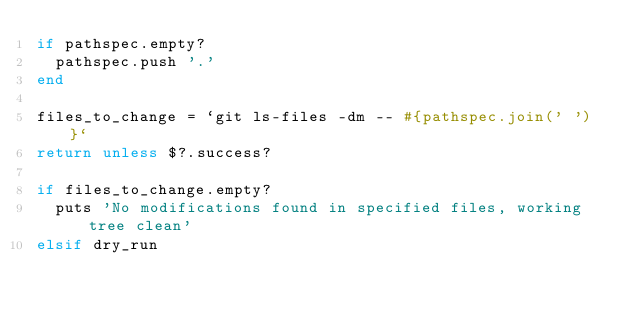Convert code to text. <code><loc_0><loc_0><loc_500><loc_500><_Ruby_>if pathspec.empty?
  pathspec.push '.'
end

files_to_change = `git ls-files -dm -- #{pathspec.join(' ')}`
return unless $?.success?

if files_to_change.empty?
  puts 'No modifications found in specified files, working tree clean'
elsif dry_run</code> 